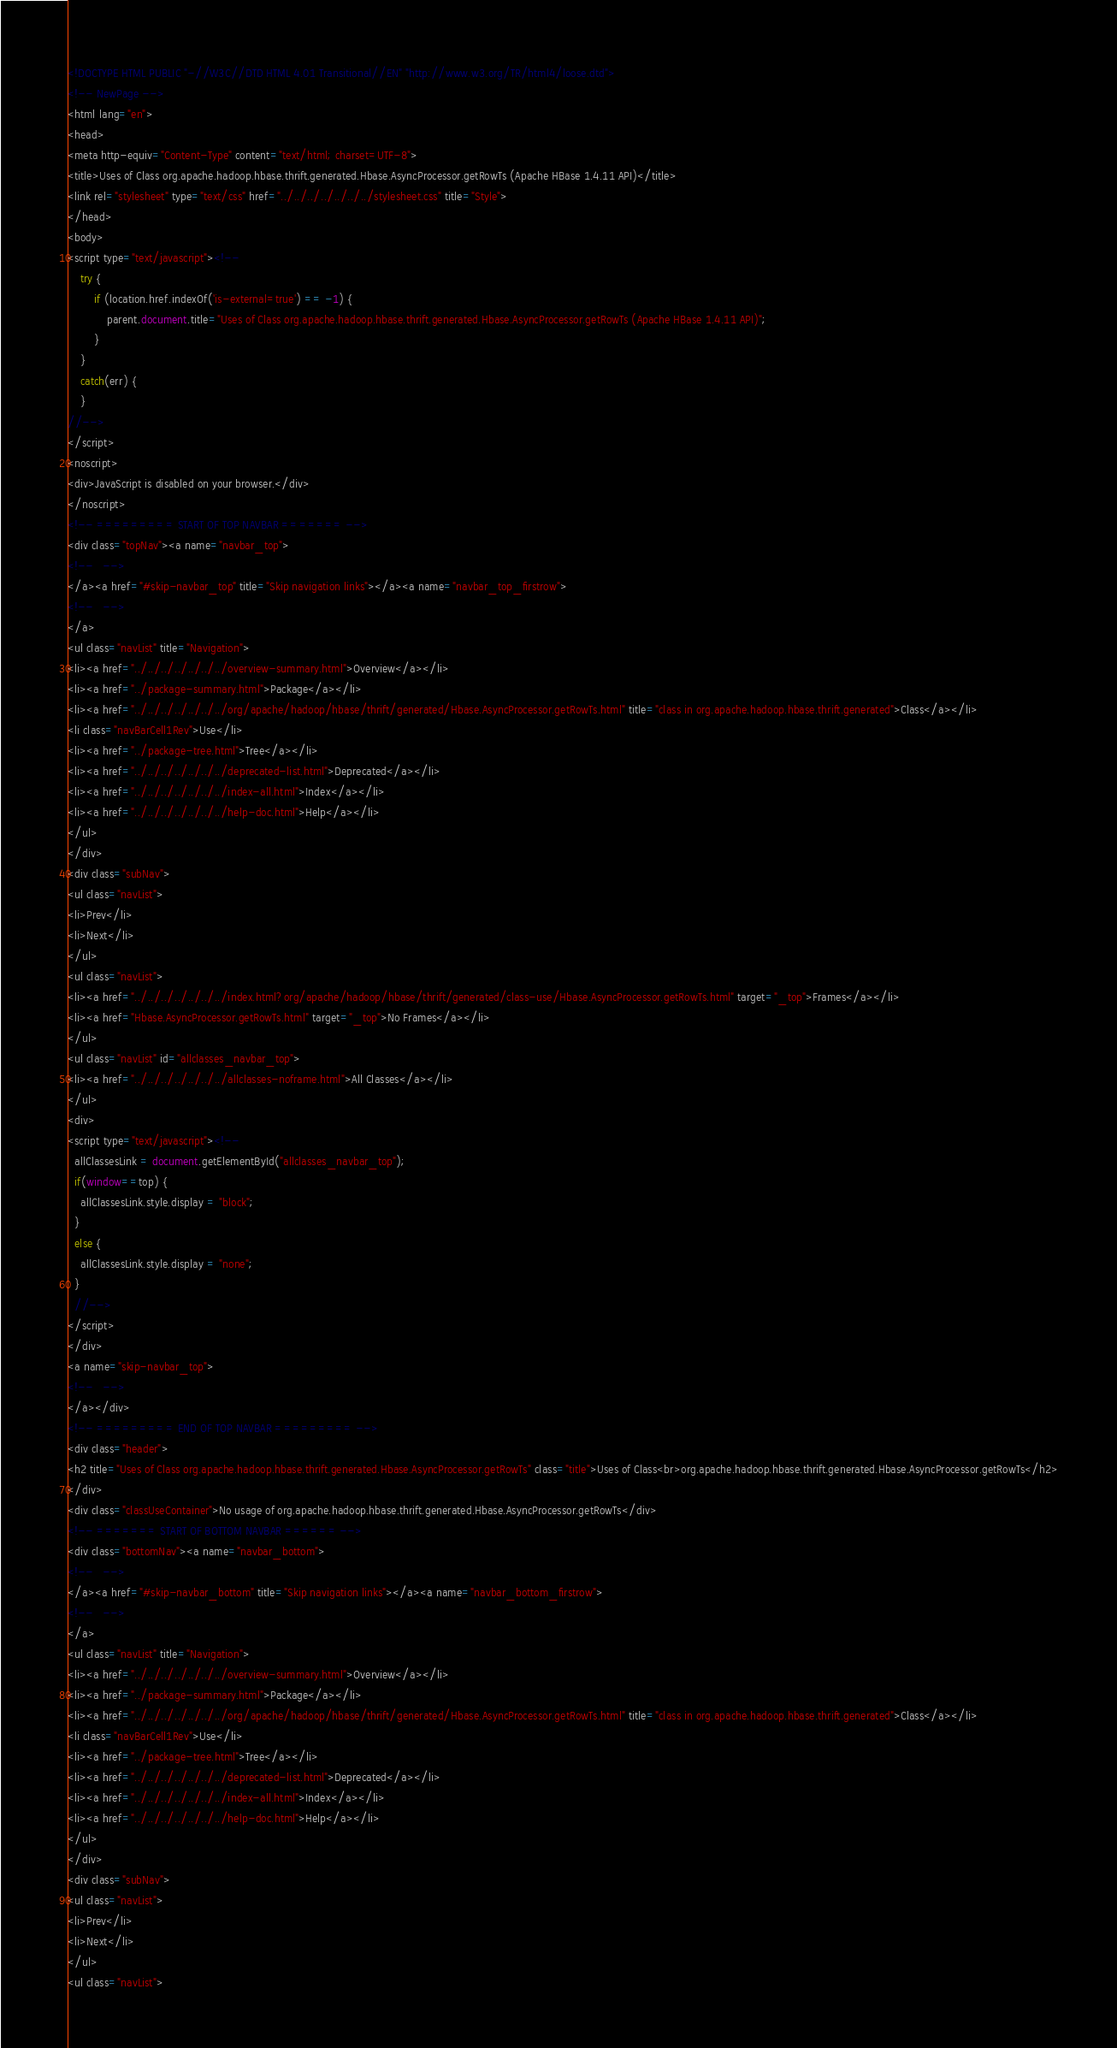Convert code to text. <code><loc_0><loc_0><loc_500><loc_500><_HTML_><!DOCTYPE HTML PUBLIC "-//W3C//DTD HTML 4.01 Transitional//EN" "http://www.w3.org/TR/html4/loose.dtd">
<!-- NewPage -->
<html lang="en">
<head>
<meta http-equiv="Content-Type" content="text/html; charset=UTF-8">
<title>Uses of Class org.apache.hadoop.hbase.thrift.generated.Hbase.AsyncProcessor.getRowTs (Apache HBase 1.4.11 API)</title>
<link rel="stylesheet" type="text/css" href="../../../../../../../stylesheet.css" title="Style">
</head>
<body>
<script type="text/javascript"><!--
    try {
        if (location.href.indexOf('is-external=true') == -1) {
            parent.document.title="Uses of Class org.apache.hadoop.hbase.thrift.generated.Hbase.AsyncProcessor.getRowTs (Apache HBase 1.4.11 API)";
        }
    }
    catch(err) {
    }
//-->
</script>
<noscript>
<div>JavaScript is disabled on your browser.</div>
</noscript>
<!-- ========= START OF TOP NAVBAR ======= -->
<div class="topNav"><a name="navbar_top">
<!--   -->
</a><a href="#skip-navbar_top" title="Skip navigation links"></a><a name="navbar_top_firstrow">
<!--   -->
</a>
<ul class="navList" title="Navigation">
<li><a href="../../../../../../../overview-summary.html">Overview</a></li>
<li><a href="../package-summary.html">Package</a></li>
<li><a href="../../../../../../../org/apache/hadoop/hbase/thrift/generated/Hbase.AsyncProcessor.getRowTs.html" title="class in org.apache.hadoop.hbase.thrift.generated">Class</a></li>
<li class="navBarCell1Rev">Use</li>
<li><a href="../package-tree.html">Tree</a></li>
<li><a href="../../../../../../../deprecated-list.html">Deprecated</a></li>
<li><a href="../../../../../../../index-all.html">Index</a></li>
<li><a href="../../../../../../../help-doc.html">Help</a></li>
</ul>
</div>
<div class="subNav">
<ul class="navList">
<li>Prev</li>
<li>Next</li>
</ul>
<ul class="navList">
<li><a href="../../../../../../../index.html?org/apache/hadoop/hbase/thrift/generated/class-use/Hbase.AsyncProcessor.getRowTs.html" target="_top">Frames</a></li>
<li><a href="Hbase.AsyncProcessor.getRowTs.html" target="_top">No Frames</a></li>
</ul>
<ul class="navList" id="allclasses_navbar_top">
<li><a href="../../../../../../../allclasses-noframe.html">All Classes</a></li>
</ul>
<div>
<script type="text/javascript"><!--
  allClassesLink = document.getElementById("allclasses_navbar_top");
  if(window==top) {
    allClassesLink.style.display = "block";
  }
  else {
    allClassesLink.style.display = "none";
  }
  //-->
</script>
</div>
<a name="skip-navbar_top">
<!--   -->
</a></div>
<!-- ========= END OF TOP NAVBAR ========= -->
<div class="header">
<h2 title="Uses of Class org.apache.hadoop.hbase.thrift.generated.Hbase.AsyncProcessor.getRowTs" class="title">Uses of Class<br>org.apache.hadoop.hbase.thrift.generated.Hbase.AsyncProcessor.getRowTs</h2>
</div>
<div class="classUseContainer">No usage of org.apache.hadoop.hbase.thrift.generated.Hbase.AsyncProcessor.getRowTs</div>
<!-- ======= START OF BOTTOM NAVBAR ====== -->
<div class="bottomNav"><a name="navbar_bottom">
<!--   -->
</a><a href="#skip-navbar_bottom" title="Skip navigation links"></a><a name="navbar_bottom_firstrow">
<!--   -->
</a>
<ul class="navList" title="Navigation">
<li><a href="../../../../../../../overview-summary.html">Overview</a></li>
<li><a href="../package-summary.html">Package</a></li>
<li><a href="../../../../../../../org/apache/hadoop/hbase/thrift/generated/Hbase.AsyncProcessor.getRowTs.html" title="class in org.apache.hadoop.hbase.thrift.generated">Class</a></li>
<li class="navBarCell1Rev">Use</li>
<li><a href="../package-tree.html">Tree</a></li>
<li><a href="../../../../../../../deprecated-list.html">Deprecated</a></li>
<li><a href="../../../../../../../index-all.html">Index</a></li>
<li><a href="../../../../../../../help-doc.html">Help</a></li>
</ul>
</div>
<div class="subNav">
<ul class="navList">
<li>Prev</li>
<li>Next</li>
</ul>
<ul class="navList"></code> 